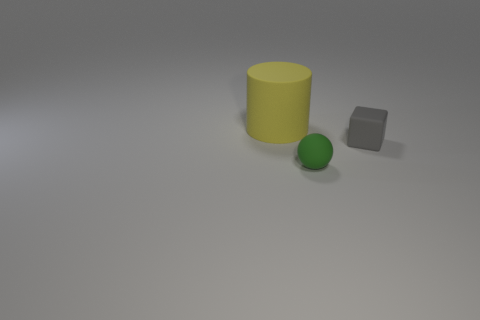Are there any big balls?
Your answer should be compact. No. Are there any gray matte blocks to the right of the tiny rubber sphere in front of the gray block?
Ensure brevity in your answer.  Yes. Are there more rubber cubes than purple blocks?
Offer a terse response. Yes. What color is the rubber object that is both to the left of the rubber cube and behind the tiny green rubber thing?
Make the answer very short. Yellow. What number of other things are the same material as the gray object?
Offer a terse response. 2. Are there fewer small things than rubber objects?
Keep it short and to the point. Yes. Is the small gray cube made of the same material as the tiny object in front of the cube?
Give a very brief answer. Yes. What shape is the small rubber object that is left of the matte block?
Your answer should be compact. Sphere. Is there anything else that has the same color as the rubber cube?
Ensure brevity in your answer.  No. Is the number of tiny rubber cubes that are in front of the block less than the number of green things?
Make the answer very short. Yes. 